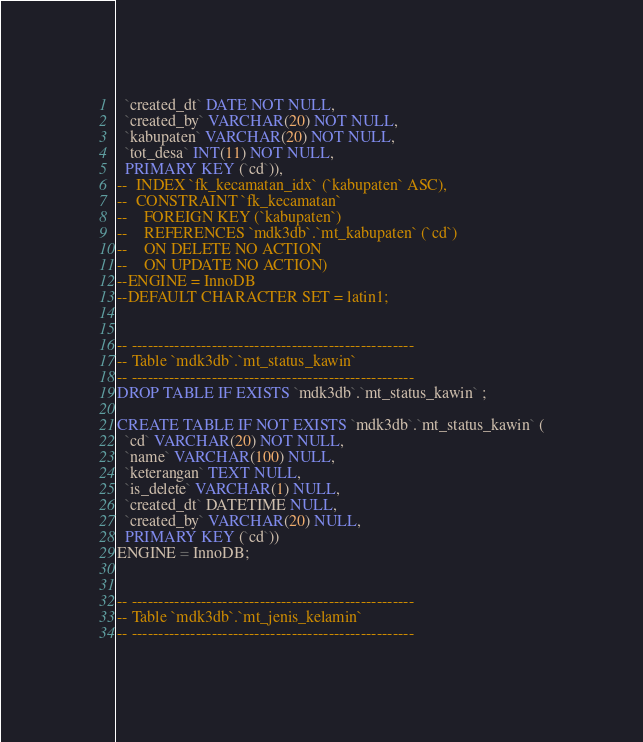Convert code to text. <code><loc_0><loc_0><loc_500><loc_500><_SQL_>  `created_dt` DATE NOT NULL,
  `created_by` VARCHAR(20) NOT NULL,
  `kabupaten` VARCHAR(20) NOT NULL,
  `tot_desa` INT(11) NOT NULL,
  PRIMARY KEY (`cd`)),
--  INDEX `fk_kecamatan_idx` (`kabupaten` ASC),
--  CONSTRAINT `fk_kecamatan`
--    FOREIGN KEY (`kabupaten`)
--    REFERENCES `mdk3db`.`mt_kabupaten` (`cd`)
--    ON DELETE NO ACTION
--    ON UPDATE NO ACTION)
--ENGINE = InnoDB
--DEFAULT CHARACTER SET = latin1;


-- -----------------------------------------------------
-- Table `mdk3db`.`mt_status_kawin`
-- -----------------------------------------------------
DROP TABLE IF EXISTS `mdk3db`.`mt_status_kawin` ;

CREATE TABLE IF NOT EXISTS `mdk3db`.`mt_status_kawin` (
  `cd` VARCHAR(20) NOT NULL,
  `name` VARCHAR(100) NULL,
  `keterangan` TEXT NULL,
  `is_delete` VARCHAR(1) NULL,
  `created_dt` DATETIME NULL,
  `created_by` VARCHAR(20) NULL,
  PRIMARY KEY (`cd`))
ENGINE = InnoDB;


-- -----------------------------------------------------
-- Table `mdk3db`.`mt_jenis_kelamin`
-- -----------------------------------------------------</code> 